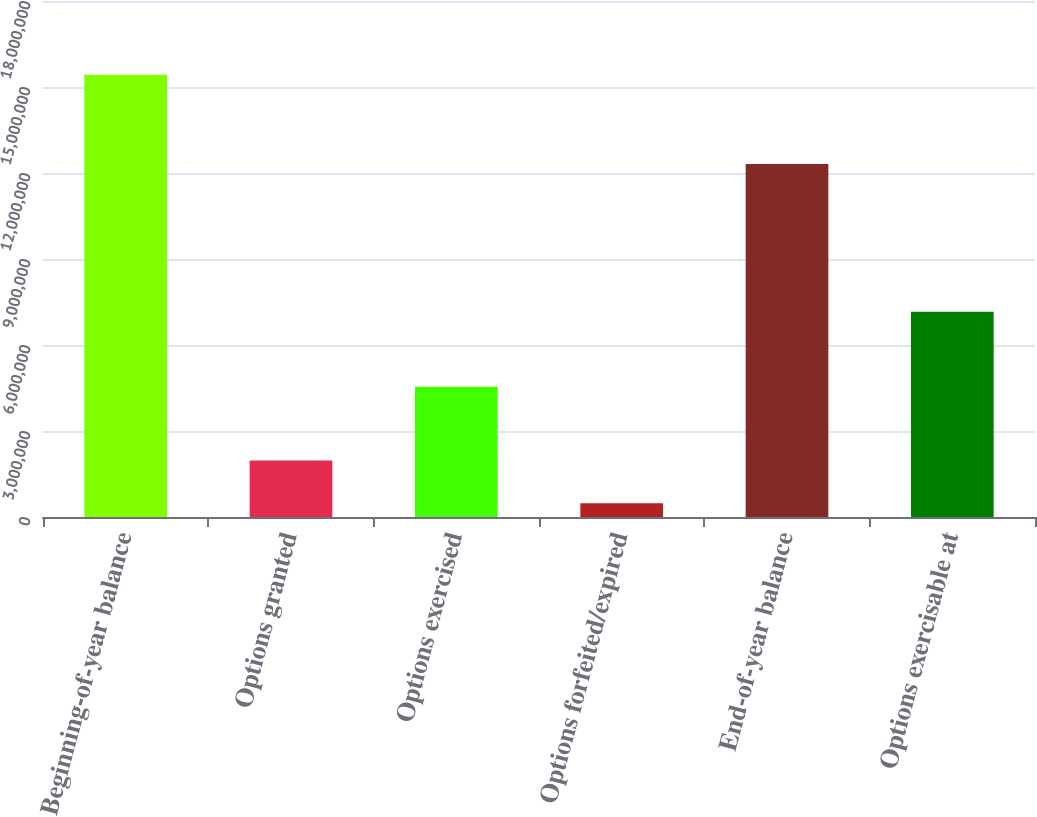<chart> <loc_0><loc_0><loc_500><loc_500><bar_chart><fcel>Beginning-of-year balance<fcel>Options granted<fcel>Options exercised<fcel>Options forfeited/expired<fcel>End-of-year balance<fcel>Options exercisable at<nl><fcel>1.54294e+07<fcel>1.97165e+06<fcel>4.54105e+06<fcel>476351<fcel>1.23101e+07<fcel>7.16288e+06<nl></chart> 